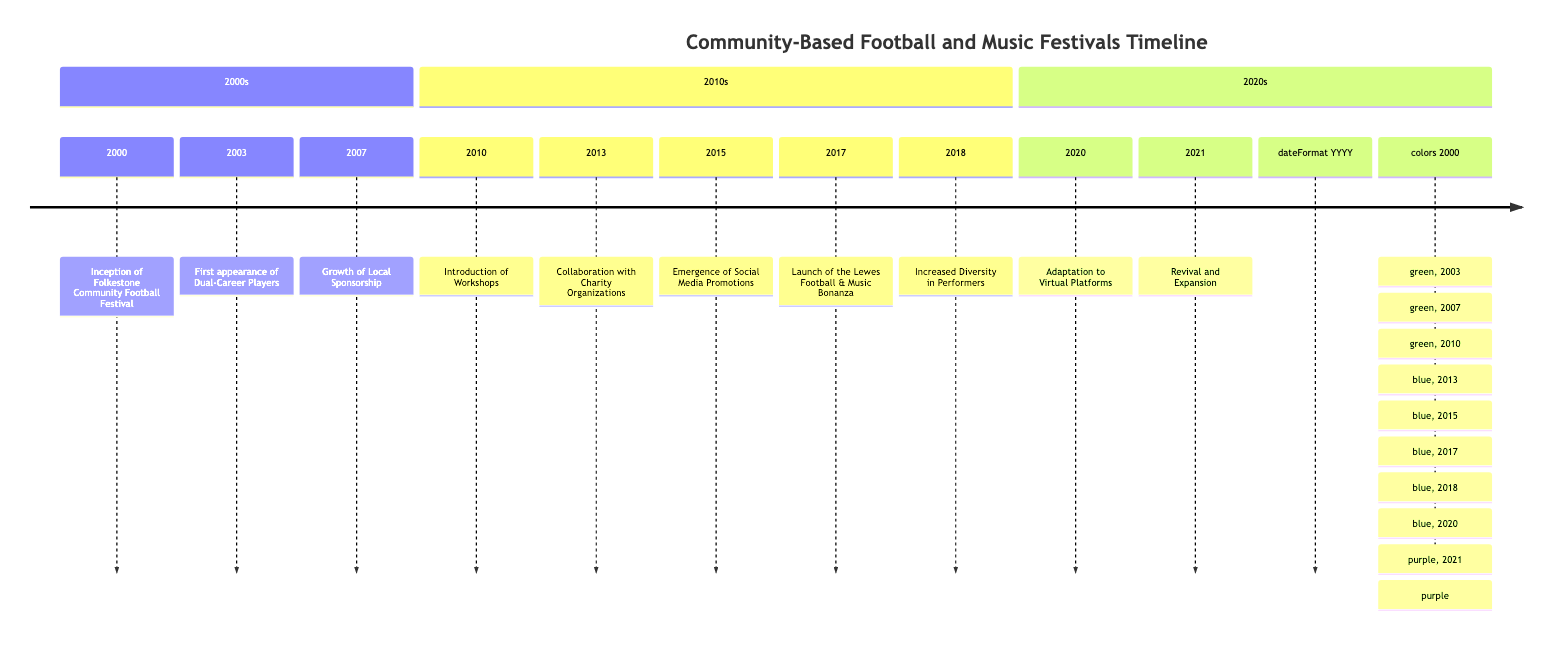What year did the Folkestone Community Football Festival begin? The diagram states that the Folkestone Community Football Festival was established in the year 2000. By locating the event on the timeline, we directly see that it is associated with the year 2000.
Answer: 2000 How many events occurred in the 2010s? By counting the events listed under the 2010s section of the timeline, we see there are five events: Introduction of Workshops, Collaboration with Charity Organizations, Emergence of Social Media Promotions, Launch of the Lewes Football & Music Bonanza, and Increased Diversity in Performers. Thus, the total is five.
Answer: 5 What is the main theme for festivals in 2017? The 2017 event is titled "Launch of the Lewes Football & Music Bonanza," which emphasizes the convergence of sports and arts within the community. This indicates that the main theme revolves around the combination of football and music.
Answer: Convergence of sports and arts Which event shows a shift to online formats due to external circumstances? The 2020 event is described as "Adaptation to Virtual Platforms," indicating a shift to online formats as a response to the COVID-19 pandemic. By examining the year 2020, this phrase makes it evident that it represents the shift.
Answer: Adaptation to Virtual Platforms What indicates the start of collaboration with charity organizations? The timeline shows that in 2013, festivals like the Hastings Community Football and Music Festival began collaborating with charity organizations, which is explicitly stated as the event for that year. This event serves as a clear indicator of this shift.
Answer: Collaboration with Charity Organizations How did local sponsorship change from 2007 to 2015? In 2007, there was "Growth of Local Sponsorship," which facilitated increased funding and participation. By 2015, the timeline highlights the "Emergence of Social Media Promotions," suggesting that local sponsorship continued to evolve by becoming more integrated with social media for better outreach. This indicates a transition from local sponsorship growth toward broader promotional tactics leveraging social media.
Answer: Evolved with social media What is described as the first combined event in 2017? The "Launch of the Lewes Football & Music Bonanza" is noted as the first combined football and music festival in the year 2017. By locating this event in the timeline, we can confirm its association with being the inaugural event of its kind.
Answer: Lewes Football & Music Bonanza What was a significant impact of social media on festivals in 2015? The event noted in 2015, "Emergence of Social Media Promotions," highlights that social media had a significant impact in promoting community football and music festivals, resulting in a considerable increase in attendance and participation. This indicates social media's role as a key promotional factor.
Answer: Significant increase in attendance In which year were workshops introduced at a festival? The timeline notes that workshops were introduced in 2010, as indicated by the event titled "Introduction of Workshops." Thus, the corresponding year is easily identified by observing this event.
Answer: 2010 